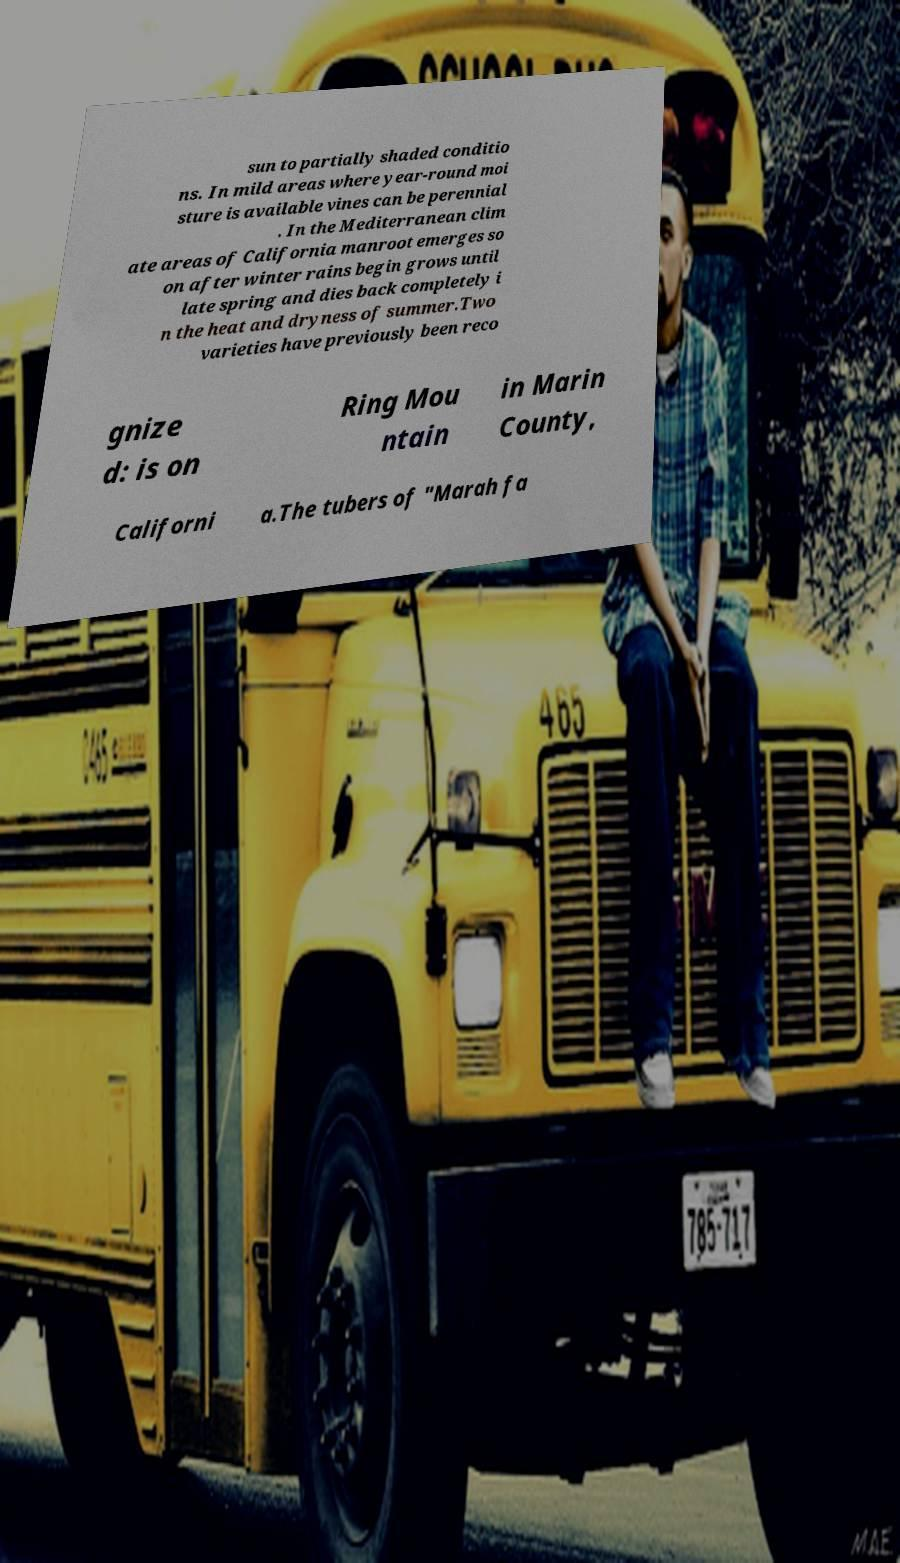Please identify and transcribe the text found in this image. sun to partially shaded conditio ns. In mild areas where year-round moi sture is available vines can be perennial . In the Mediterranean clim ate areas of California manroot emerges so on after winter rains begin grows until late spring and dies back completely i n the heat and dryness of summer.Two varieties have previously been reco gnize d: is on Ring Mou ntain in Marin County, Californi a.The tubers of "Marah fa 